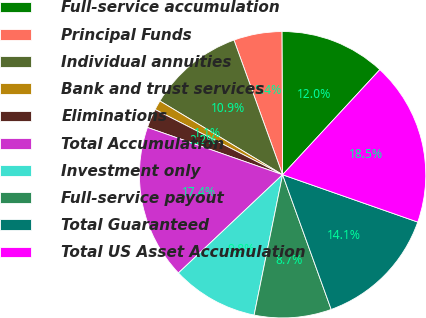Convert chart to OTSL. <chart><loc_0><loc_0><loc_500><loc_500><pie_chart><fcel>Full-service accumulation<fcel>Principal Funds<fcel>Individual annuities<fcel>Bank and trust services<fcel>Eliminations<fcel>Total Accumulation<fcel>Investment only<fcel>Full-service payout<fcel>Total Guaranteed<fcel>Total US Asset Accumulation<nl><fcel>11.96%<fcel>5.44%<fcel>10.87%<fcel>1.09%<fcel>2.17%<fcel>17.39%<fcel>9.78%<fcel>8.7%<fcel>14.13%<fcel>18.48%<nl></chart> 